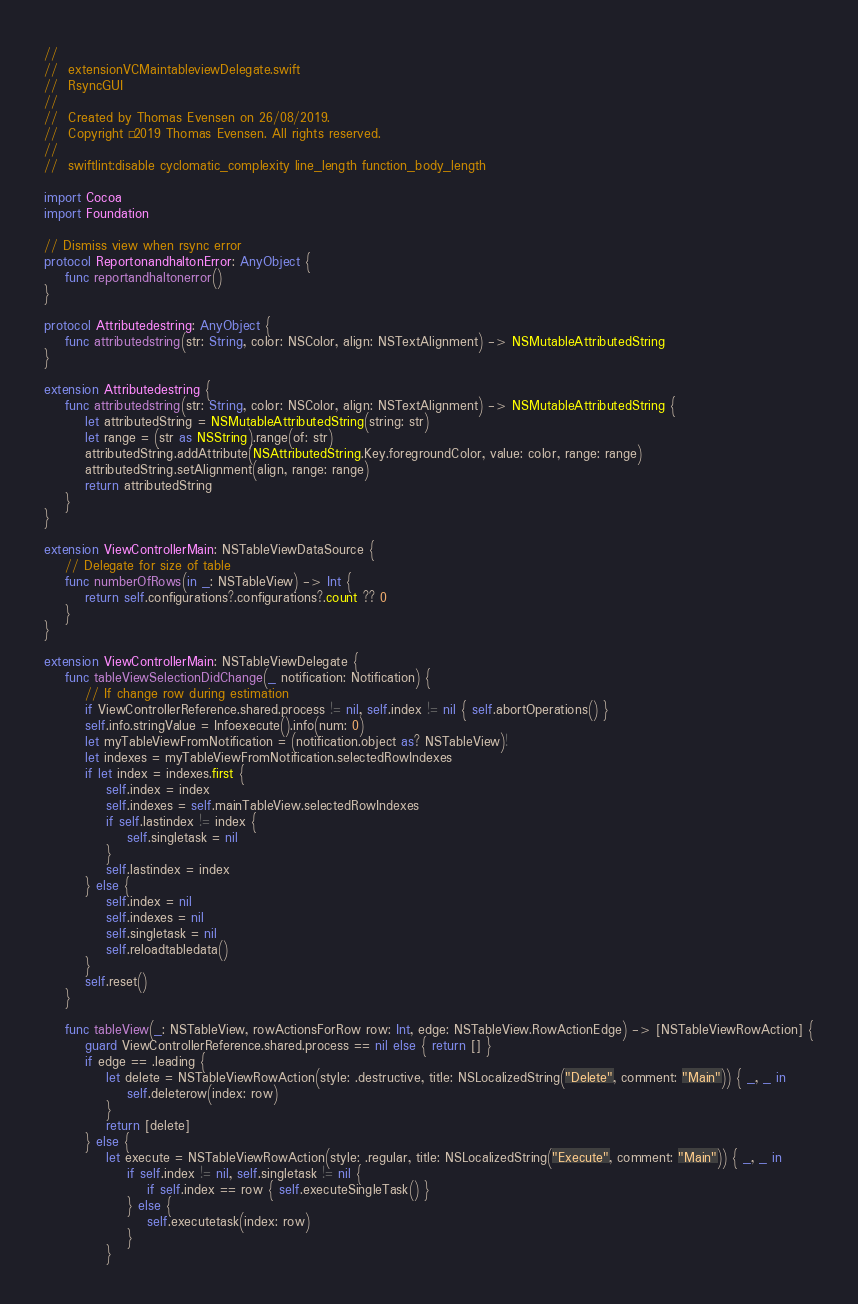<code> <loc_0><loc_0><loc_500><loc_500><_Swift_>//
//  extensionVCMaintableviewDelegate.swift
//  RsyncGUI
//
//  Created by Thomas Evensen on 26/08/2019.
//  Copyright © 2019 Thomas Evensen. All rights reserved.
//
//  swiftlint:disable cyclomatic_complexity line_length function_body_length

import Cocoa
import Foundation

// Dismiss view when rsync error
protocol ReportonandhaltonError: AnyObject {
    func reportandhaltonerror()
}

protocol Attributedestring: AnyObject {
    func attributedstring(str: String, color: NSColor, align: NSTextAlignment) -> NSMutableAttributedString
}

extension Attributedestring {
    func attributedstring(str: String, color: NSColor, align: NSTextAlignment) -> NSMutableAttributedString {
        let attributedString = NSMutableAttributedString(string: str)
        let range = (str as NSString).range(of: str)
        attributedString.addAttribute(NSAttributedString.Key.foregroundColor, value: color, range: range)
        attributedString.setAlignment(align, range: range)
        return attributedString
    }
}

extension ViewControllerMain: NSTableViewDataSource {
    // Delegate for size of table
    func numberOfRows(in _: NSTableView) -> Int {
        return self.configurations?.configurations?.count ?? 0
    }
}

extension ViewControllerMain: NSTableViewDelegate {
    func tableViewSelectionDidChange(_ notification: Notification) {
        // If change row during estimation
        if ViewControllerReference.shared.process != nil, self.index != nil { self.abortOperations() }
        self.info.stringValue = Infoexecute().info(num: 0)
        let myTableViewFromNotification = (notification.object as? NSTableView)!
        let indexes = myTableViewFromNotification.selectedRowIndexes
        if let index = indexes.first {
            self.index = index
            self.indexes = self.mainTableView.selectedRowIndexes
            if self.lastindex != index {
                self.singletask = nil
            }
            self.lastindex = index
        } else {
            self.index = nil
            self.indexes = nil
            self.singletask = nil
            self.reloadtabledata()
        }
        self.reset()
    }

    func tableView(_: NSTableView, rowActionsForRow row: Int, edge: NSTableView.RowActionEdge) -> [NSTableViewRowAction] {
        guard ViewControllerReference.shared.process == nil else { return [] }
        if edge == .leading {
            let delete = NSTableViewRowAction(style: .destructive, title: NSLocalizedString("Delete", comment: "Main")) { _, _ in
                self.deleterow(index: row)
            }
            return [delete]
        } else {
            let execute = NSTableViewRowAction(style: .regular, title: NSLocalizedString("Execute", comment: "Main")) { _, _ in
                if self.index != nil, self.singletask != nil {
                    if self.index == row { self.executeSingleTask() }
                } else {
                    self.executetask(index: row)
                }
            }</code> 